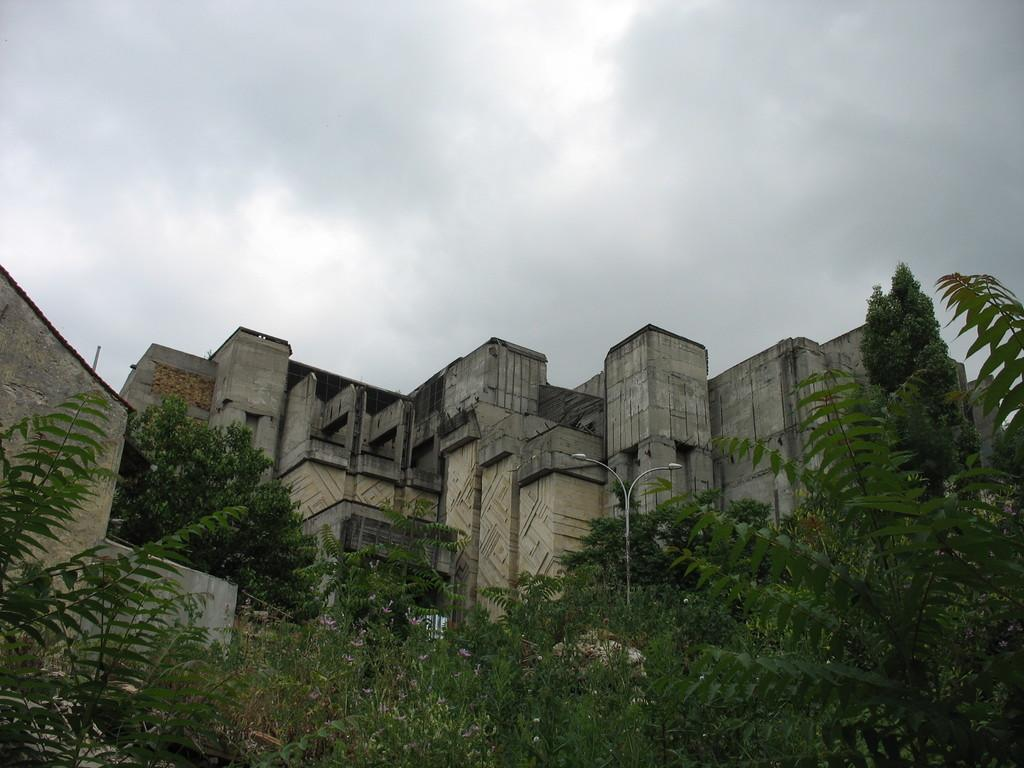What type of natural elements can be seen in the image? There are trees in the image. What man-made structures are visible in the image? There are light poles and buildings in the image. What is visible in the background of the image? The sky is visible in the background of the image, and it appears to be cloudy. What type of guitar can be seen hanging from the trees in the image? There is no guitar present in the image; it features trees, light poles, buildings, and a cloudy sky. 